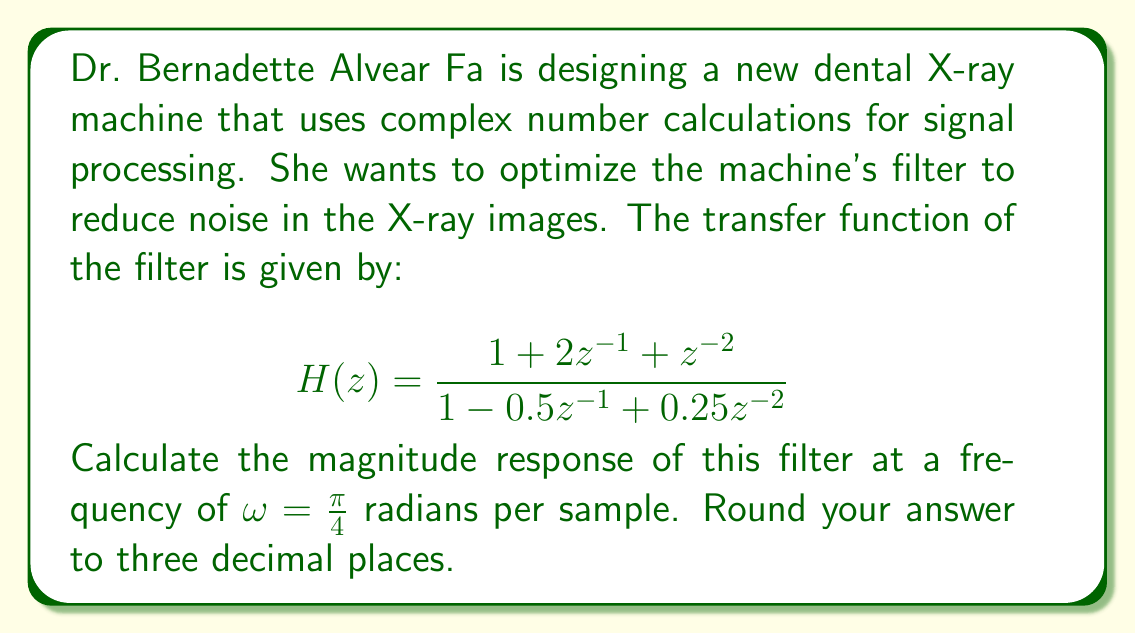Can you answer this question? To solve this problem, we'll follow these steps:

1) The magnitude response of a filter is given by $|H(e^{j\omega})|$, where we substitute $z = e^{j\omega}$ into the transfer function.

2) Let's substitute $z = e^{j\pi/4}$ into our transfer function:

   $$H(e^{j\pi/4}) = \frac{1 + 2e^{-j\pi/4} + e^{-j\pi/2}}{1 - 0.5e^{-j\pi/4} + 0.25e^{-j\pi/2}}$$

3) Recall Euler's formula: $e^{-j\theta} = \cos\theta - j\sin\theta$

4) For $\theta = \frac{\pi}{4}$:
   $e^{-j\pi/4} = \cos(\frac{\pi}{4}) - j\sin(\frac{\pi}{4}) = \frac{\sqrt{2}}{2} - j\frac{\sqrt{2}}{2}$

5) For $\theta = \frac{\pi}{2}$:
   $e^{-j\pi/2} = \cos(\frac{\pi}{2}) - j\sin(\frac{\pi}{2}) = -j$

6) Substituting these into our equation:

   $$H(e^{j\pi/4}) = \frac{1 + 2(\frac{\sqrt{2}}{2} - j\frac{\sqrt{2}}{2}) + (-j)}{1 - 0.5(\frac{\sqrt{2}}{2} - j\frac{\sqrt{2}}{2}) + 0.25(-j)}$$

7) Simplify the numerator and denominator separately:

   Numerator: $1 + \sqrt{2} - j\sqrt{2} - j = (1 + \sqrt{2}) - j(1 + \sqrt{2})$
   Denominator: $1 - \frac{\sqrt{2}}{4} + j\frac{\sqrt{2}}{4} - j\frac{1}{4} = (1 - \frac{\sqrt{2}}{4}) + j(\frac{\sqrt{2}}{4} - \frac{1}{4})$

8) The magnitude response is the absolute value of this complex number:

   $$|H(e^{j\pi/4})| = \sqrt{\frac{(1 + \sqrt{2})^2 + (1 + \sqrt{2})^2}{(1 - \frac{\sqrt{2}}{4})^2 + (\frac{\sqrt{2}}{4} - \frac{1}{4})^2}}$$

9) Simplify and calculate:

   $$|H(e^{j\pi/4})| = \sqrt{\frac{2(1 + \sqrt{2})^2}{(\frac{4-\sqrt{2}}{4})^2 + (\frac{\sqrt{2}-1}{4})^2}} \approx 2.613$$
Answer: The magnitude response of the filter at $\omega = \frac{\pi}{4}$ is approximately 2.613. 